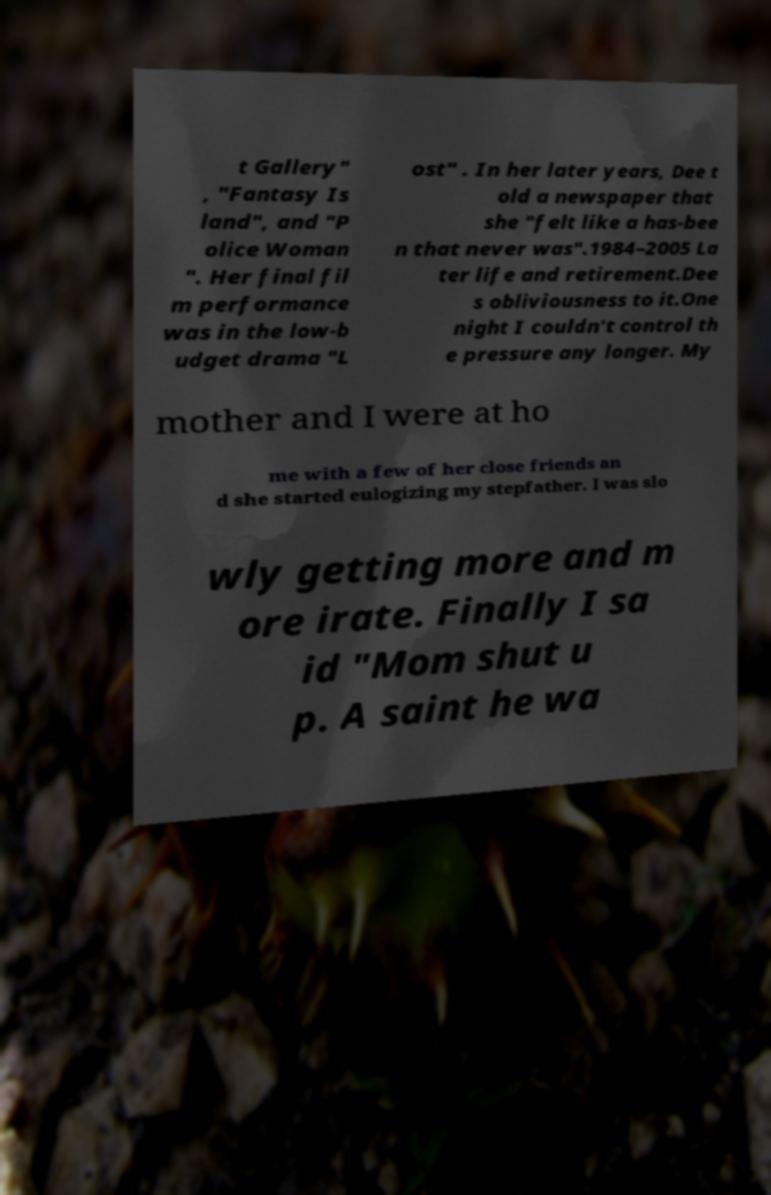Please read and relay the text visible in this image. What does it say? t Gallery" , "Fantasy Is land", and "P olice Woman ". Her final fil m performance was in the low-b udget drama "L ost" . In her later years, Dee t old a newspaper that she "felt like a has-bee n that never was".1984–2005 La ter life and retirement.Dee s obliviousness to it.One night I couldn't control th e pressure any longer. My mother and I were at ho me with a few of her close friends an d she started eulogizing my stepfather. I was slo wly getting more and m ore irate. Finally I sa id "Mom shut u p. A saint he wa 